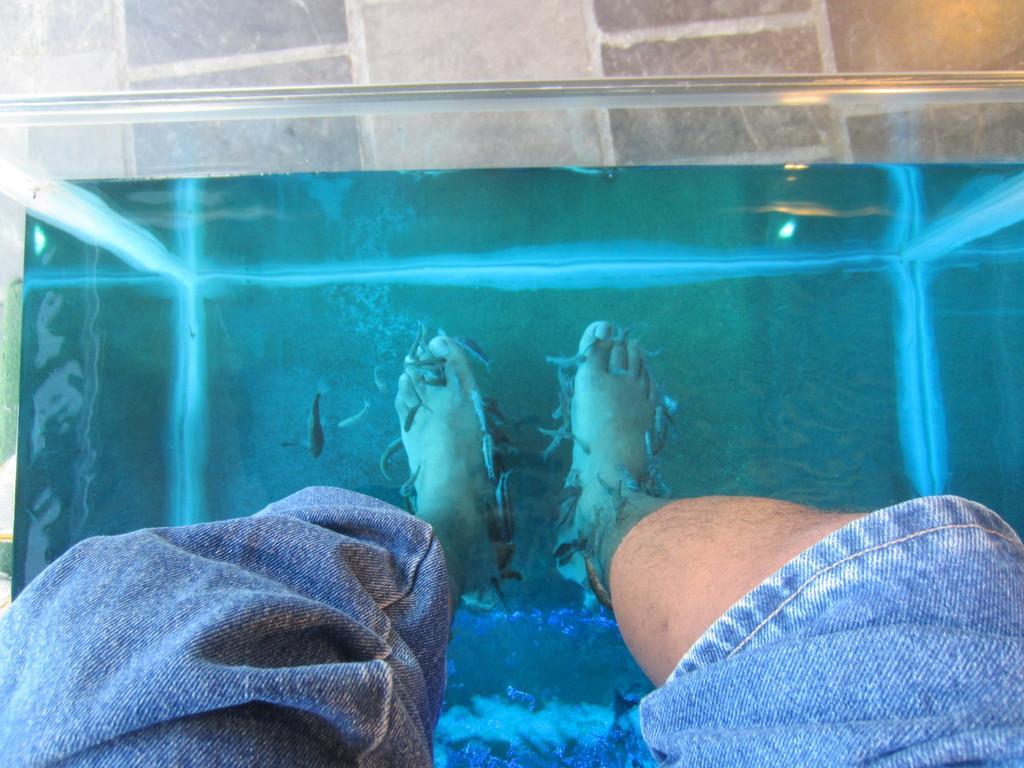How would you summarize this image in a sentence or two? In this picture we can see a person legs in water,fish. 